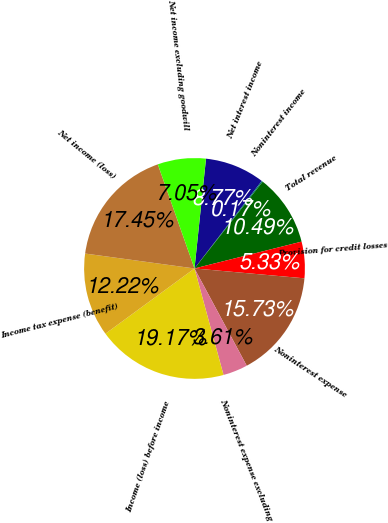Convert chart to OTSL. <chart><loc_0><loc_0><loc_500><loc_500><pie_chart><fcel>Net interest income<fcel>Noninterest income<fcel>Total revenue<fcel>Provision for credit losses<fcel>Noninterest expense<fcel>Noninterest expense excluding<fcel>Income (loss) before income<fcel>Income tax expense (benefit)<fcel>Net income (loss)<fcel>Net income excluding goodwill<nl><fcel>8.77%<fcel>0.17%<fcel>10.49%<fcel>5.33%<fcel>15.73%<fcel>3.61%<fcel>19.17%<fcel>12.22%<fcel>17.45%<fcel>7.05%<nl></chart> 